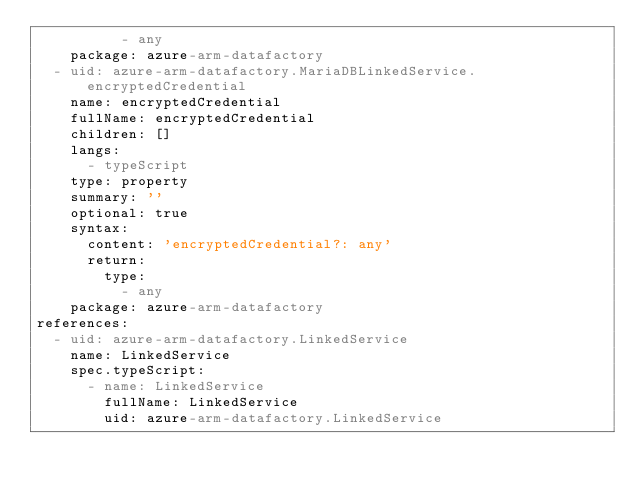<code> <loc_0><loc_0><loc_500><loc_500><_YAML_>          - any
    package: azure-arm-datafactory
  - uid: azure-arm-datafactory.MariaDBLinkedService.encryptedCredential
    name: encryptedCredential
    fullName: encryptedCredential
    children: []
    langs:
      - typeScript
    type: property
    summary: ''
    optional: true
    syntax:
      content: 'encryptedCredential?: any'
      return:
        type:
          - any
    package: azure-arm-datafactory
references:
  - uid: azure-arm-datafactory.LinkedService
    name: LinkedService
    spec.typeScript:
      - name: LinkedService
        fullName: LinkedService
        uid: azure-arm-datafactory.LinkedService
</code> 